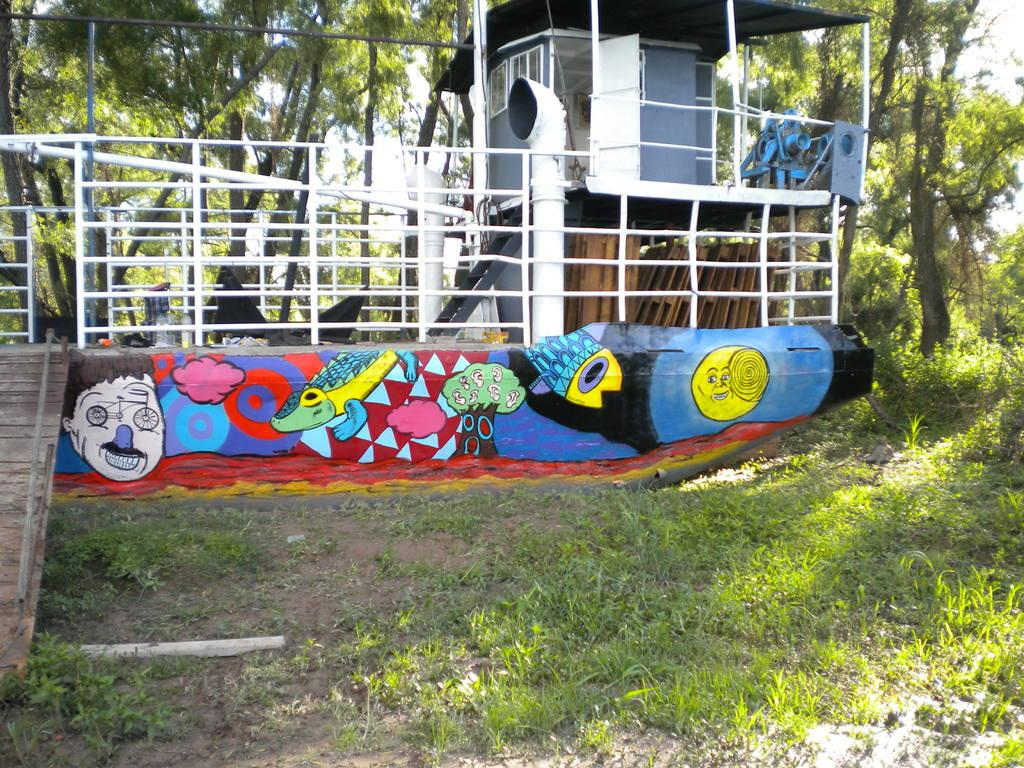What is the main subject of the image? The main subject of the image is a ship. Where is the ship located in the image? The ship is on the ground in the image. What can be seen in the background of the image? There are trees, plants, and the sky visible in the background of the image. How many matches are on the ship in the image? There are no matches present in the image; it features a ship on the ground with a background of trees, plants, and the sky. 